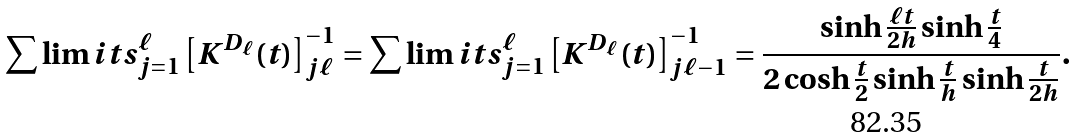<formula> <loc_0><loc_0><loc_500><loc_500>\sum \lim i t s _ { j = 1 } ^ { \ell } \left [ K ^ { D _ { \ell } } ( t ) \right ] _ { j \ell } ^ { - 1 } = \sum \lim i t s _ { j = 1 } ^ { \ell } \left [ K ^ { D _ { \ell } } ( t ) \right ] _ { j \ell - 1 } ^ { - 1 } = \frac { \sinh \frac { \ell t } { 2 h } \sinh \frac { t } { 4 } } { 2 \cosh \frac { t } { 2 } \sinh \frac { t } { h } \sinh \frac { t } { 2 h } } .</formula> 